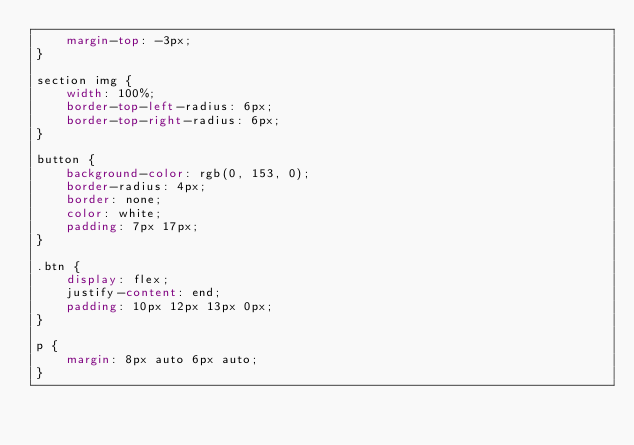<code> <loc_0><loc_0><loc_500><loc_500><_CSS_>    margin-top: -3px;
}

section img {
    width: 100%;
    border-top-left-radius: 6px;
    border-top-right-radius: 6px;
}

button {
    background-color: rgb(0, 153, 0);
    border-radius: 4px;
    border: none;
    color: white;
    padding: 7px 17px;
}

.btn {
    display: flex;
    justify-content: end;
    padding: 10px 12px 13px 0px;
}

p {
    margin: 8px auto 6px auto;
}</code> 